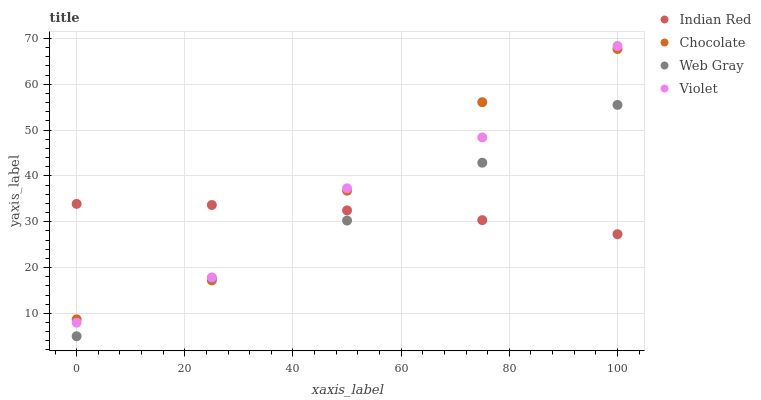Does Web Gray have the minimum area under the curve?
Answer yes or no. Yes. Does Chocolate have the maximum area under the curve?
Answer yes or no. Yes. Does Indian Red have the minimum area under the curve?
Answer yes or no. No. Does Indian Red have the maximum area under the curve?
Answer yes or no. No. Is Web Gray the smoothest?
Answer yes or no. Yes. Is Violet the roughest?
Answer yes or no. Yes. Is Indian Red the smoothest?
Answer yes or no. No. Is Indian Red the roughest?
Answer yes or no. No. Does Web Gray have the lowest value?
Answer yes or no. Yes. Does Indian Red have the lowest value?
Answer yes or no. No. Does Violet have the highest value?
Answer yes or no. Yes. Does Web Gray have the highest value?
Answer yes or no. No. Is Web Gray less than Violet?
Answer yes or no. Yes. Is Violet greater than Web Gray?
Answer yes or no. Yes. Does Web Gray intersect Indian Red?
Answer yes or no. Yes. Is Web Gray less than Indian Red?
Answer yes or no. No. Is Web Gray greater than Indian Red?
Answer yes or no. No. Does Web Gray intersect Violet?
Answer yes or no. No. 